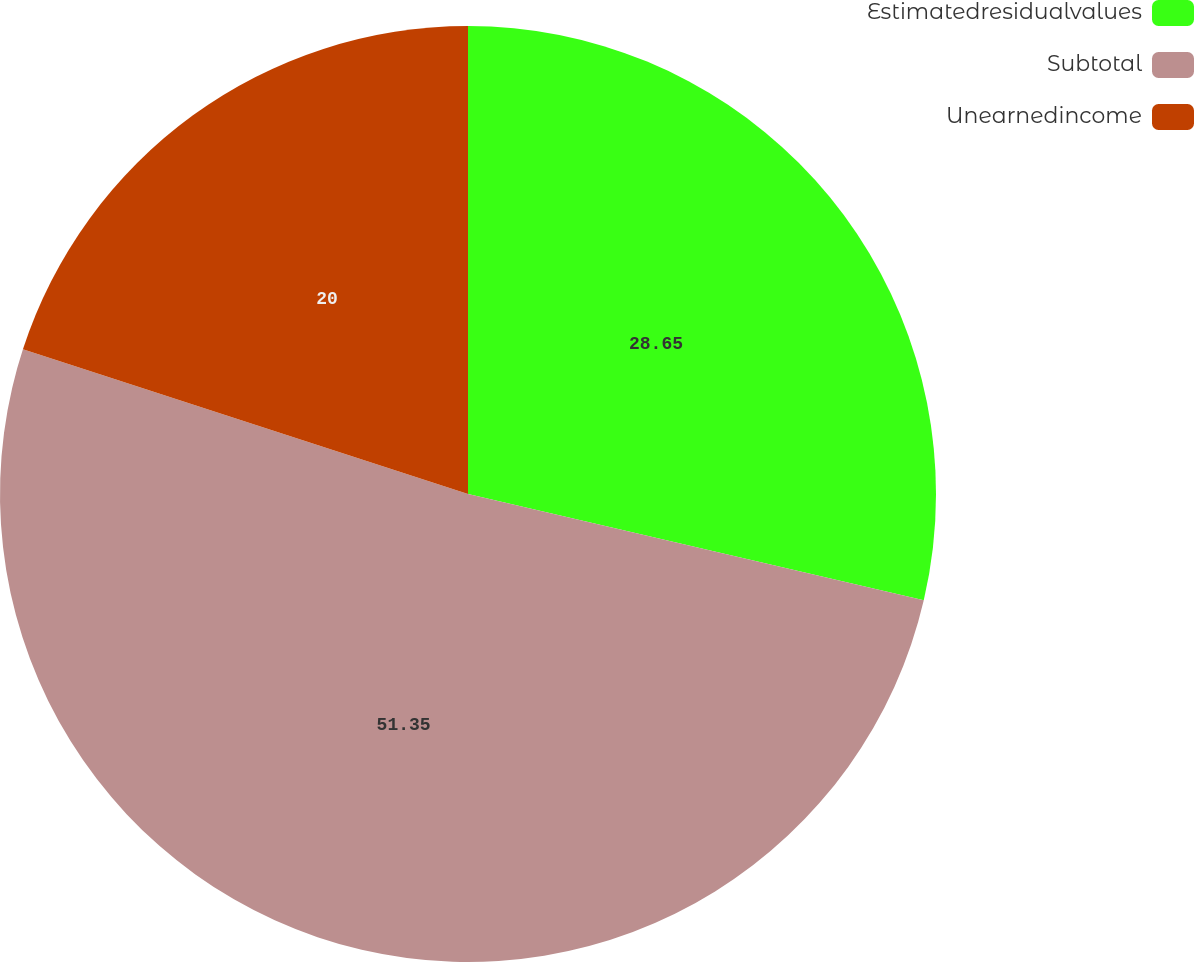Convert chart. <chart><loc_0><loc_0><loc_500><loc_500><pie_chart><fcel>Estimatedresidualvalues<fcel>Subtotal<fcel>Unearnedincome<nl><fcel>28.65%<fcel>51.36%<fcel>20.0%<nl></chart> 